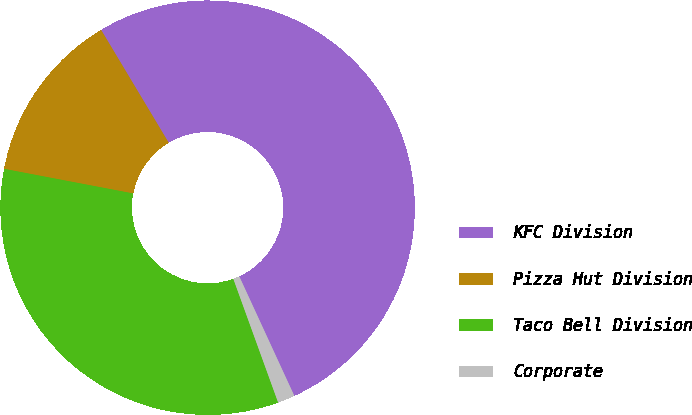Convert chart. <chart><loc_0><loc_0><loc_500><loc_500><pie_chart><fcel>KFC Division<fcel>Pizza Hut Division<fcel>Taco Bell Division<fcel>Corporate<nl><fcel>51.72%<fcel>13.41%<fcel>33.53%<fcel>1.34%<nl></chart> 